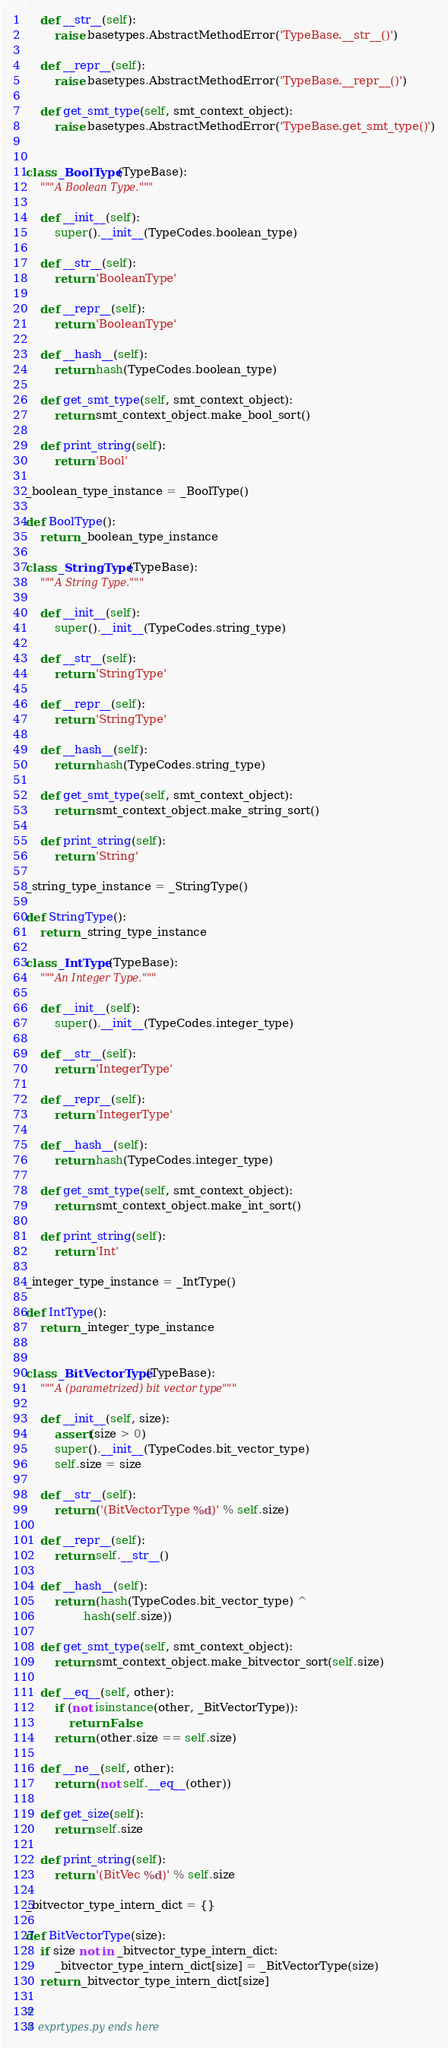<code> <loc_0><loc_0><loc_500><loc_500><_Python_>
    def __str__(self):
        raise basetypes.AbstractMethodError('TypeBase.__str__()')

    def __repr__(self):
        raise basetypes.AbstractMethodError('TypeBase.__repr__()')

    def get_smt_type(self, smt_context_object):
        raise basetypes.AbstractMethodError('TypeBase.get_smt_type()')


class _BoolType(TypeBase):
    """A Boolean Type."""

    def __init__(self):
        super().__init__(TypeCodes.boolean_type)

    def __str__(self):
        return 'BooleanType'

    def __repr__(self):
        return 'BooleanType'

    def __hash__(self):
        return hash(TypeCodes.boolean_type)

    def get_smt_type(self, smt_context_object):
        return smt_context_object.make_bool_sort()

    def print_string(self):
        return 'Bool'

_boolean_type_instance = _BoolType()

def BoolType():
    return _boolean_type_instance

class _StringType(TypeBase):
    """A String Type."""

    def __init__(self):
        super().__init__(TypeCodes.string_type)

    def __str__(self):
        return 'StringType'

    def __repr__(self):
        return 'StringType'

    def __hash__(self):
        return hash(TypeCodes.string_type)

    def get_smt_type(self, smt_context_object):
        return smt_context_object.make_string_sort()

    def print_string(self):
        return 'String'

_string_type_instance = _StringType()

def StringType():
    return _string_type_instance

class _IntType(TypeBase):
    """An Integer Type."""

    def __init__(self):
        super().__init__(TypeCodes.integer_type)

    def __str__(self):
        return 'IntegerType'

    def __repr__(self):
        return 'IntegerType'

    def __hash__(self):
        return hash(TypeCodes.integer_type)

    def get_smt_type(self, smt_context_object):
        return smt_context_object.make_int_sort()

    def print_string(self):
        return 'Int'

_integer_type_instance = _IntType()

def IntType():
    return _integer_type_instance


class _BitVectorType(TypeBase):
    """A (parametrized) bit vector type"""

    def __init__(self, size):
        assert(size > 0)
        super().__init__(TypeCodes.bit_vector_type)
        self.size = size

    def __str__(self):
        return ('(BitVectorType %d)' % self.size)

    def __repr__(self):
        return self.__str__()

    def __hash__(self):
        return (hash(TypeCodes.bit_vector_type) ^
                hash(self.size))

    def get_smt_type(self, smt_context_object):
        return smt_context_object.make_bitvector_sort(self.size)

    def __eq__(self, other):
        if (not isinstance(other, _BitVectorType)):
            return False
        return (other.size == self.size)

    def __ne__(self, other):
        return (not self.__eq__(other))

    def get_size(self):
        return self.size

    def print_string(self):
        return '(BitVec %d)' % self.size

_bitvector_type_intern_dict = {}

def BitVectorType(size):
    if size not in _bitvector_type_intern_dict:
        _bitvector_type_intern_dict[size] = _BitVectorType(size)
    return _bitvector_type_intern_dict[size]

#
# exprtypes.py ends here
</code> 